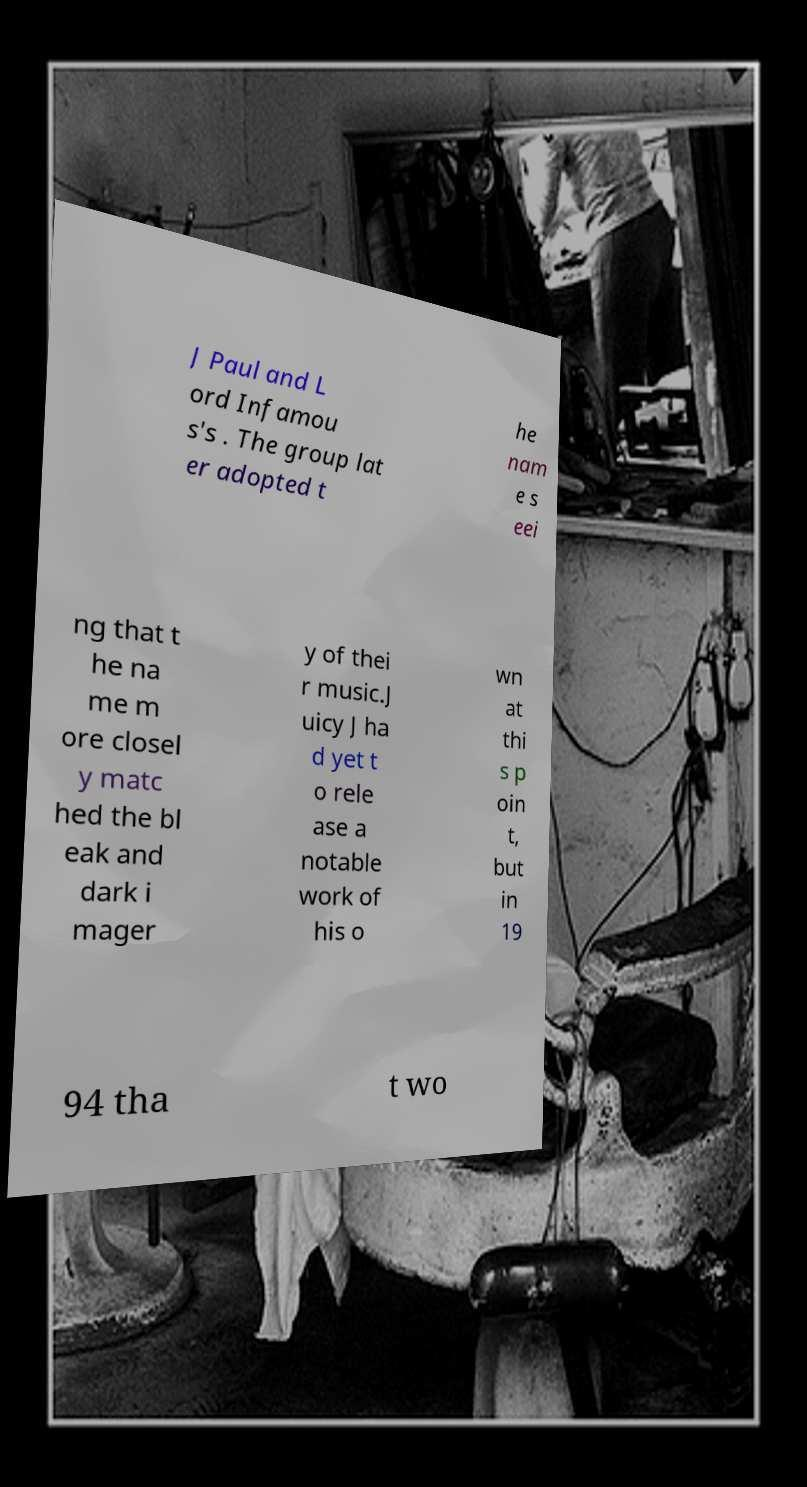Could you extract and type out the text from this image? J Paul and L ord Infamou s's . The group lat er adopted t he nam e s eei ng that t he na me m ore closel y matc hed the bl eak and dark i mager y of thei r music.J uicy J ha d yet t o rele ase a notable work of his o wn at thi s p oin t, but in 19 94 tha t wo 